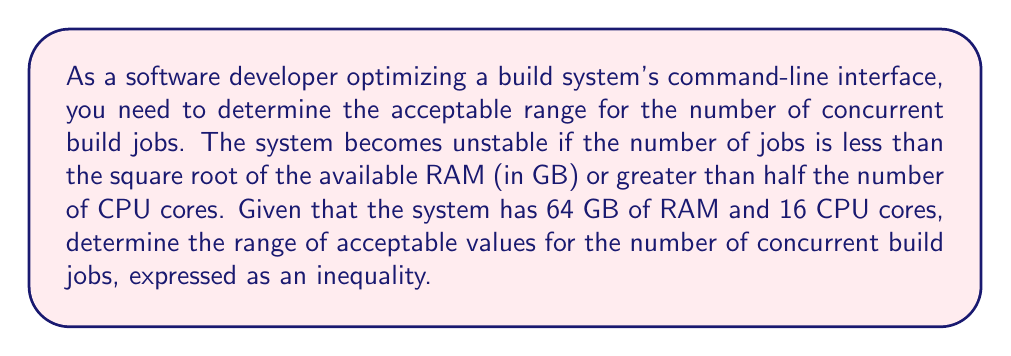Help me with this question. Let's approach this step-by-step:

1) Let $x$ be the number of concurrent build jobs.

2) For the lower bound:
   The number of jobs must be greater than or equal to the square root of the available RAM.
   $x \geq \sqrt{64} = 8$

3) For the upper bound:
   The number of jobs must be less than or equal to half the number of CPU cores.
   $x \leq \frac{16}{2} = 8$

4) Combining these inequalities:
   $8 \leq x \leq 8$

5) In this case, the lower and upper bounds are the same, meaning there's only one acceptable value.

6) We can express this as an inequality:
   $x = 8$

This means the number of concurrent build jobs must be exactly 8 to ensure system stability given the constraints.
Answer: $x = 8$ 